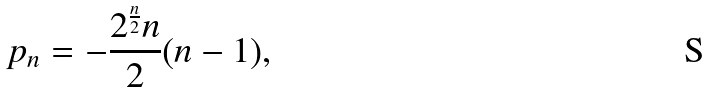Convert formula to latex. <formula><loc_0><loc_0><loc_500><loc_500>p _ { n } = - \frac { 2 ^ { \frac { n } { 2 } } n } 2 ( n - 1 ) ,</formula> 